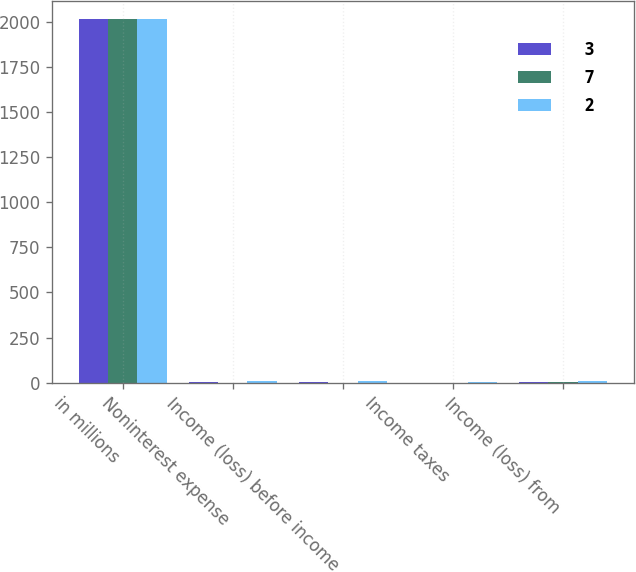Convert chart to OTSL. <chart><loc_0><loc_0><loc_500><loc_500><stacked_bar_chart><ecel><fcel>in millions<fcel>Noninterest expense<fcel>Income (loss) before income<fcel>Income taxes<fcel>Income (loss) from<nl><fcel>3<fcel>2014<fcel>4<fcel>4<fcel>1<fcel>3<nl><fcel>7<fcel>2013<fcel>1<fcel>1<fcel>1<fcel>2<nl><fcel>2<fcel>2012<fcel>10<fcel>10<fcel>3<fcel>7<nl></chart> 